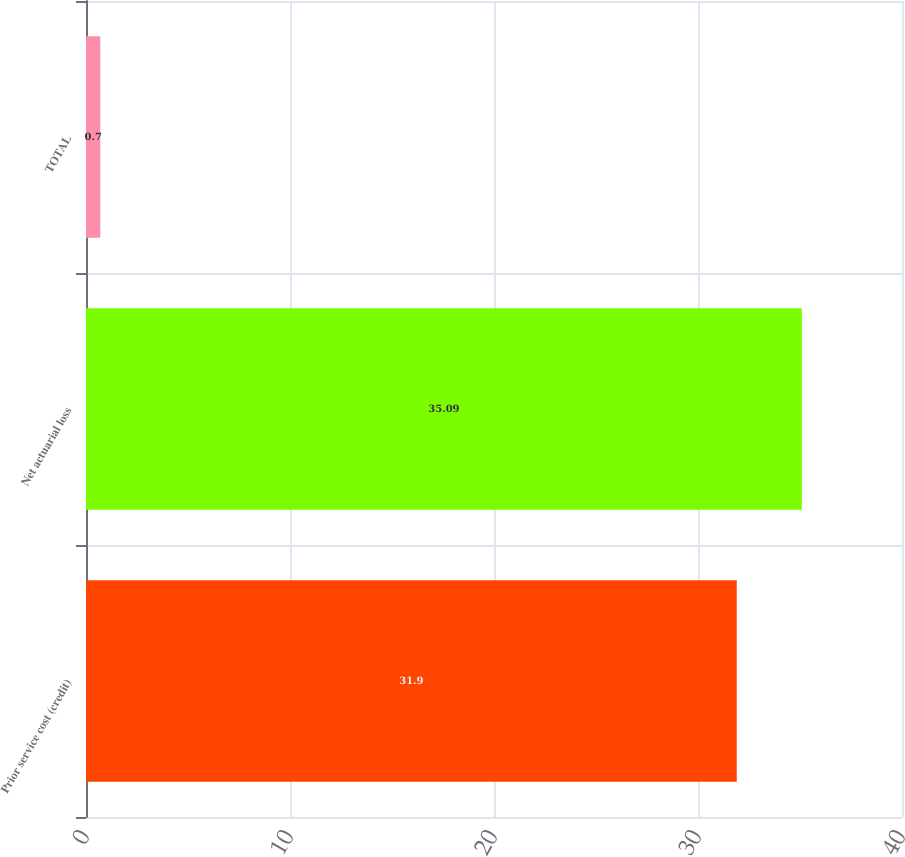Convert chart. <chart><loc_0><loc_0><loc_500><loc_500><bar_chart><fcel>Prior service cost (credit)<fcel>Net actuarial loss<fcel>TOTAL<nl><fcel>31.9<fcel>35.09<fcel>0.7<nl></chart> 